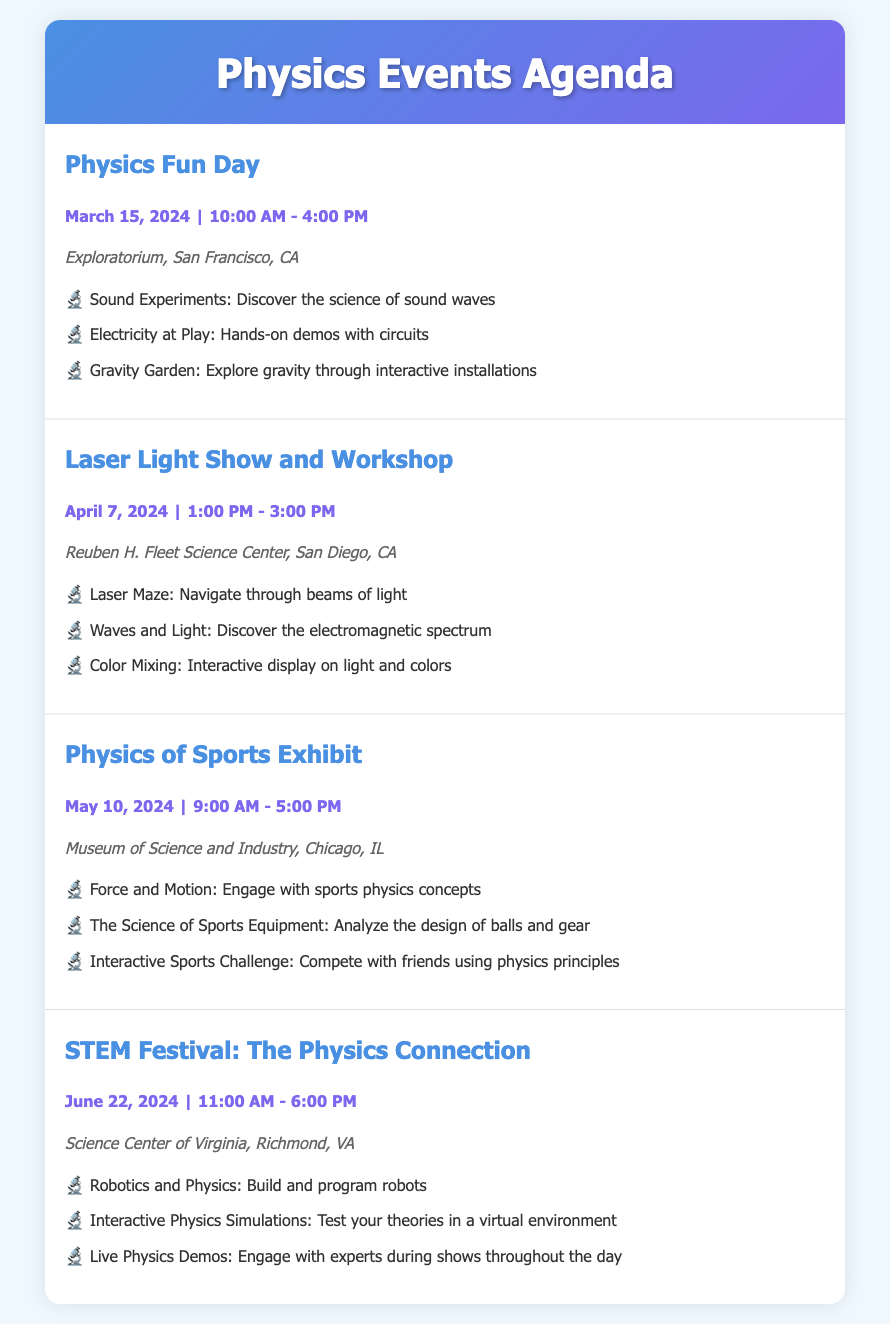What is the date of the Physics Fun Day? The date is listed in the document under the event details for Physics Fun Day.
Answer: March 15, 2024 Where is the Laser Light Show and Workshop taking place? The location is specified in the event details for the Laser Light Show and Workshop.
Answer: Reuben H. Fleet Science Center, San Diego, CA What time does the Physics of Sports Exhibit start? The start time is mentioned in the event details for Physics of Sports Exhibit.
Answer: 9:00 AM How many events are listed in the document? The number of events can be counted based on the entries provided.
Answer: 4 Which event features interactive sports challenges? The event name is given in the document that details an interactive sports challenge.
Answer: Physics of Sports Exhibit What is the main theme of the STEM Festival? The theme is described in the title of the event in the document.
Answer: The Physics Connection What type of experiments are included in the Physics Fun Day? The document lists specific experiments featured during the Physics Fun Day.
Answer: Sound Experiments, Electricity at Play, Gravity Garden What is the date range for the events listed? The overall date range can be determined by examining the dates of the first and last events.
Answer: March 15, 2024 - June 22, 2024 How long does the Laser Light Show and Workshop last? The duration is specified in the event details for the Laser Light Show and Workshop.
Answer: 2 hours 